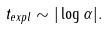Convert formula to latex. <formula><loc_0><loc_0><loc_500><loc_500>t _ { e x p l } \sim | \log { \alpha } | .</formula> 